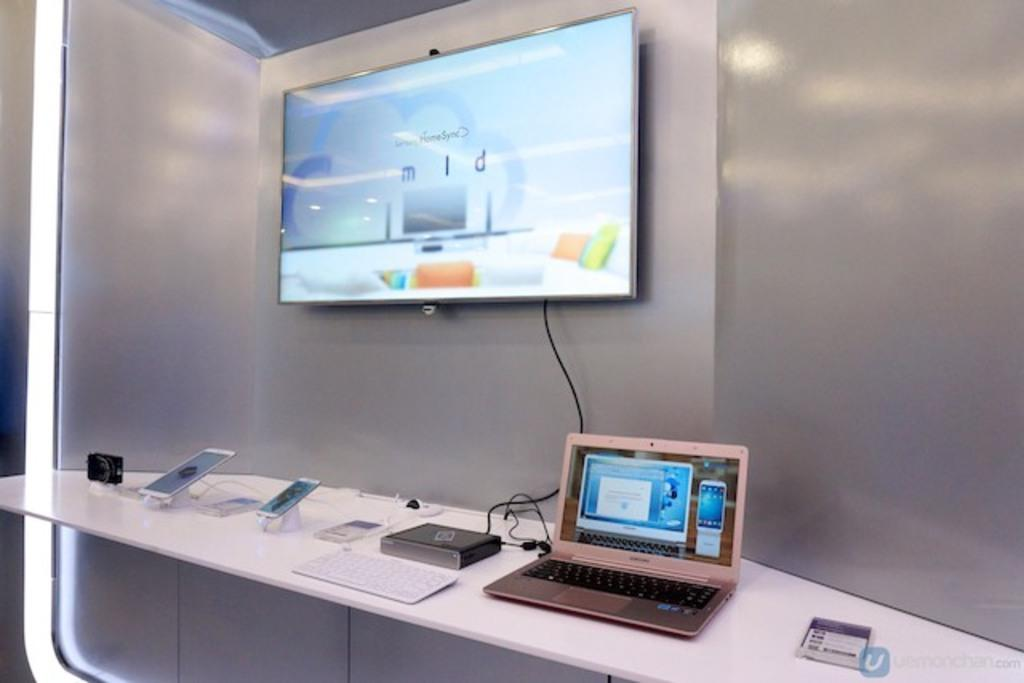What type of space is depicted in the image? There is a room in the image. What piece of furniture is present in the room? There is a table in the room. What electronic devices can be seen on the table? There is a laptop, a CPU, a battery, a mobile, and an iPad on the table. What can be seen in the background of the image? There is a screen and a wall visible in the background. What type of sign can be seen hanging from the string in the image? There is no sign or string present in the image. Can you describe the yak that is sitting next to the table in the image? There is no yak present in the image; it is a room with a table and electronic devices. 